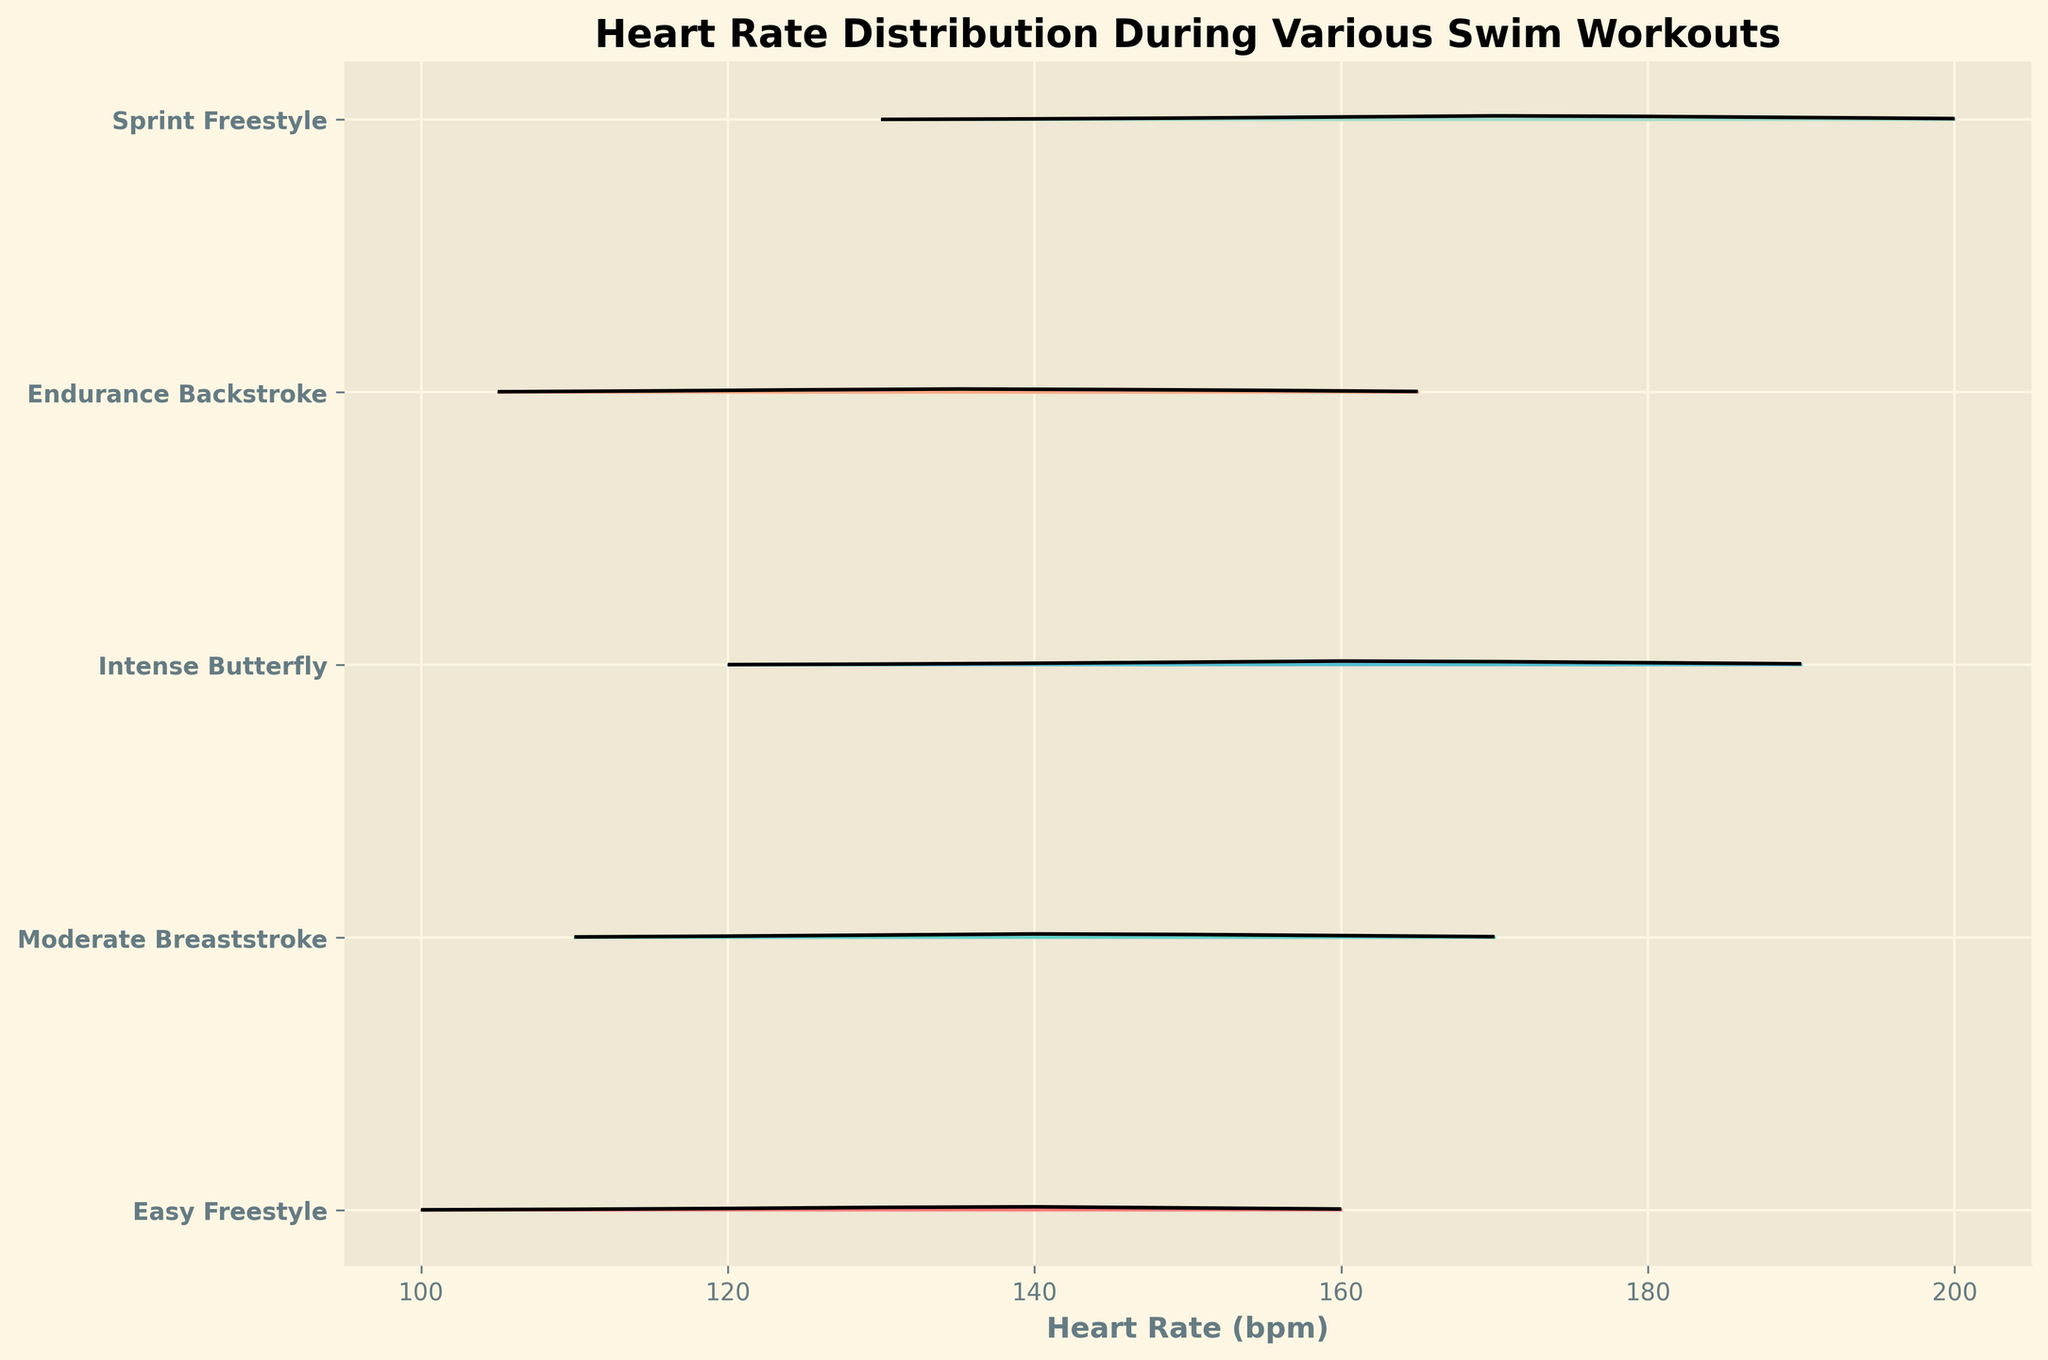What is the title of the figure? The title is displayed prominently at the top of the figure. It should be clear and easy to read.
Answer: Heart Rate Distribution During Various Swim Workouts Which workout has the highest heart rate distribution peak? To determine this, find the workout that reaches the highest point on the y-axis in the plot.
Answer: Intense Butterfly What is the general trend of heart rates in the Easy Freestyle workout? Observing the placement and density of the lines for Easy Freestyle, you can see the range and density values that are most common. The heart rate peaks and decreases.
Answer: Peaks around 140 bpm and then decreases How do Moderate Breaststroke and Sprint Freestyle heart rate distributions compare in terms of shape and peak heart rates? Compare the shape of the bell curves and the height of the peaks for both workouts. Check which has a smoother curve and their peak positions.
Answer: Moderate Breaststroke peaks at 140-150 bpm; Sprint Freestyle peaks at 170 bpm Which workout shows the widest range of heart rates? Look at the x-axis spread for each workout; the one that extends over the widest range of heart rates.
Answer: Intense Butterfly Is there any overlap in heart rate distributions between Endurance Backstroke and Moderate Breaststroke? Identify the heart rate ranges for both workouts and check for common values.
Answer: Yes, around 135-165 bpm What is the common heart rate range for all workouts? Find the overlapping heart rates range if any exist, among all the workouts displayed.
Answer: 130-160 bpm Compare the density distribution peaks of sprinting and easy workouts. Which is narrower and higher? Compare the density shapes and their height for Sprint Freestyle and Easy Freestyle workouts.
Answer: Sprint Freestyle; higher and narrower What is the average heart rate at the maximum peak for Intense Butterfly? Identify the peak density value and the corresponding heart rate for Intense Butterfly and then calculate the heart rate at that peak.
Answer: 160 bpm Which workout has the most consistent heart rate distribution? Check which workout has the smallest spread in the density plot indicating consistent heart rates.
Answer: Easy Freestyle 